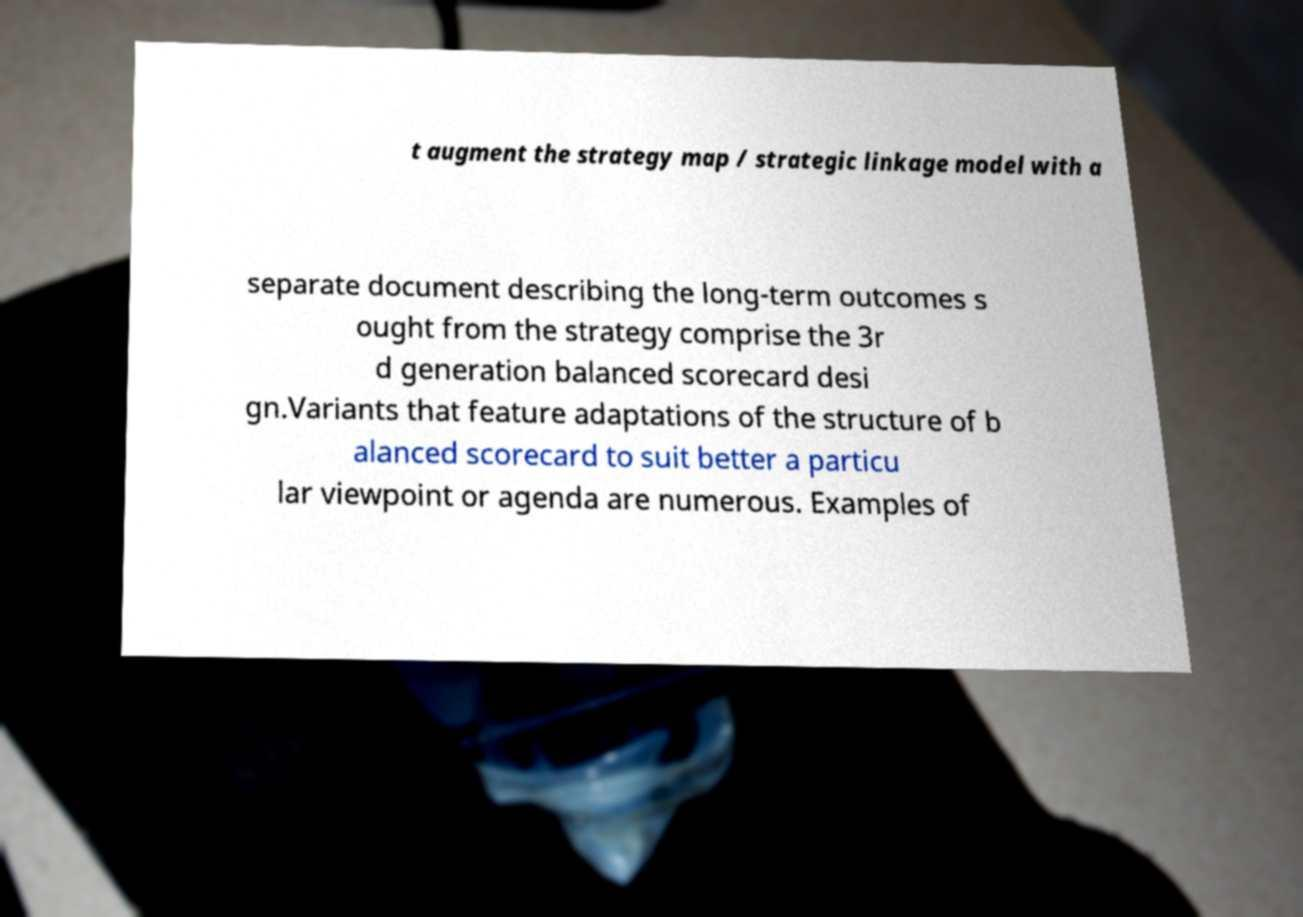Can you accurately transcribe the text from the provided image for me? t augment the strategy map / strategic linkage model with a separate document describing the long-term outcomes s ought from the strategy comprise the 3r d generation balanced scorecard desi gn.Variants that feature adaptations of the structure of b alanced scorecard to suit better a particu lar viewpoint or agenda are numerous. Examples of 